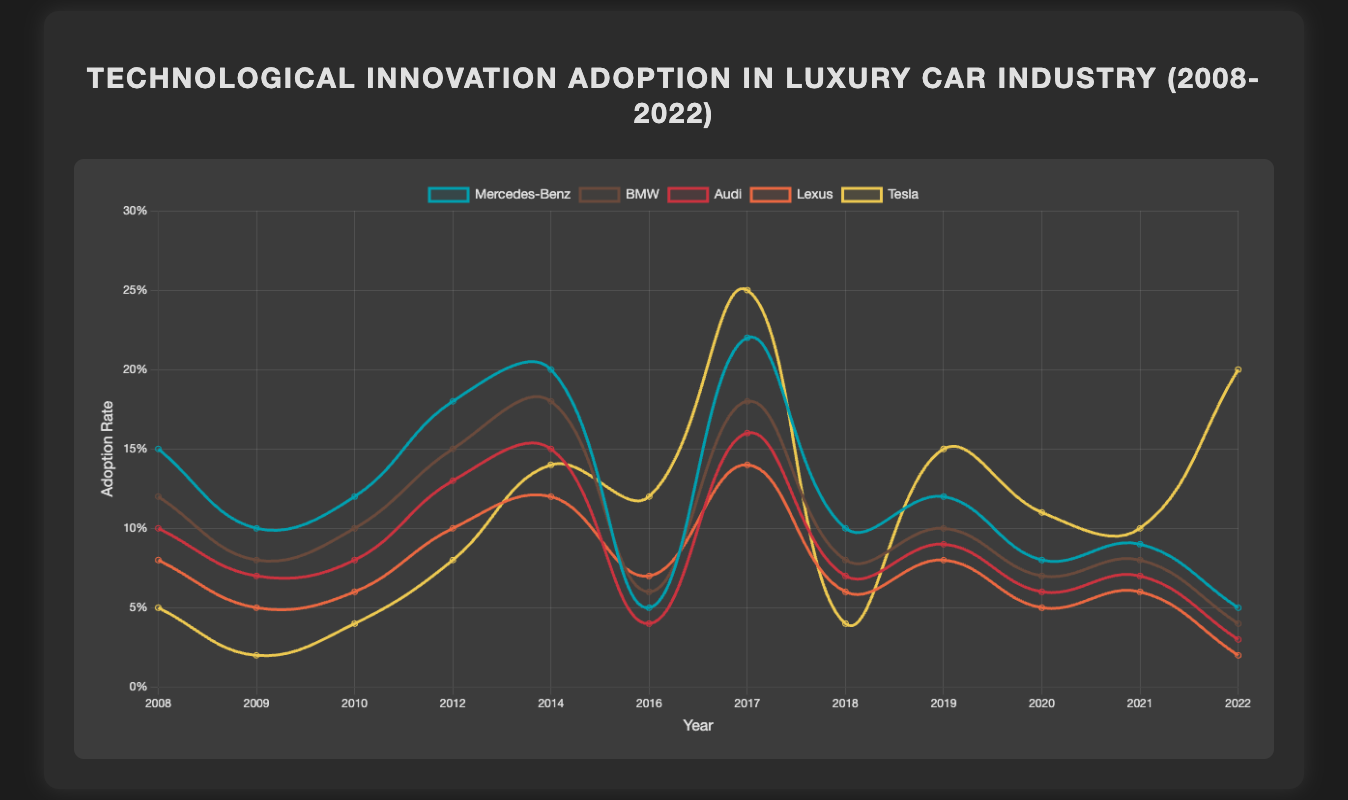What was the highest adoption rate for any technological innovation by Mercedes-Benz? The highest adoption rate for Mercedes-Benz can be identified by observing the peak points in the Mercedes-Benz line. The highest point is at 0.22 in 2017 for "Semi-Autonomous Driving".
Answer: 0.22 in 2017 Which company had the highest adoption rate for "Fully Autonomous Driving" in 2022? By identifying the data points for 2022 and comparing the values, Tesla has the highest adoption rate for "Fully Autonomous Driving" at 0.20.
Answer: Tesla Was there any innovation where Lexus had a higher adoption rate than Mercedes-Benz? Lexus never had a higher adoption rate than Mercedes-Benz for any innovation, as all Lexus values are consistently lower than those of Mercedes-Benz across all years.
Answer: No Which year had the largest difference in adoption rates between Tesla and BMW for any innovation? The year with the largest difference between Tesla and BMW can be found by comparing the adoption rates for each year. In 2022, the difference is the most significant with Tesla at 0.20 and BMW at 0.04, making a difference of 0.16.
Answer: 2022 In terms of adoption rate growth from 2008 to 2022, which company showed the most rapid increase for any single innovation? To find the most rapid increase, subtract the adoption rates in 2008 from those in 2022 for all companies and identify the highest increment. Tesla showed the most rapid increase with a change from 0.05 in 2008 to 0.25 in 2017 for "Semi-Autonomous Driving", which is an increment of 0.20.
Answer: Tesla How many innovations had an adoption rate greater than 0.15 for Audi? By inspecting the Audi line across all years, only "Autonomous Parking" in 2014 and "Semi-Autonomous Driving" in 2017 had an adoption rate greater than 0.15.
Answer: 2 Which innovation in 2019 had the most significant adoption rate difference between Mercedes-Benz and Tesla? In 2019, for "Artificial Intelligence for In-Car Assistants", Tesla had an adoption rate of 0.15 and Mercedes-Benz had 0.12. Thus, the difference is 0.03.
Answer: Artificial Intelligence for In-Car Assistants Which technology showed the lowest adoption rate across all companies in 2012? By comparing the adoption rates across all companies for 2012, "Heads-Up Display" has the lowest adoption rate for Tesla at 0.08.
Answer: Heads-Up Display by Tesla 